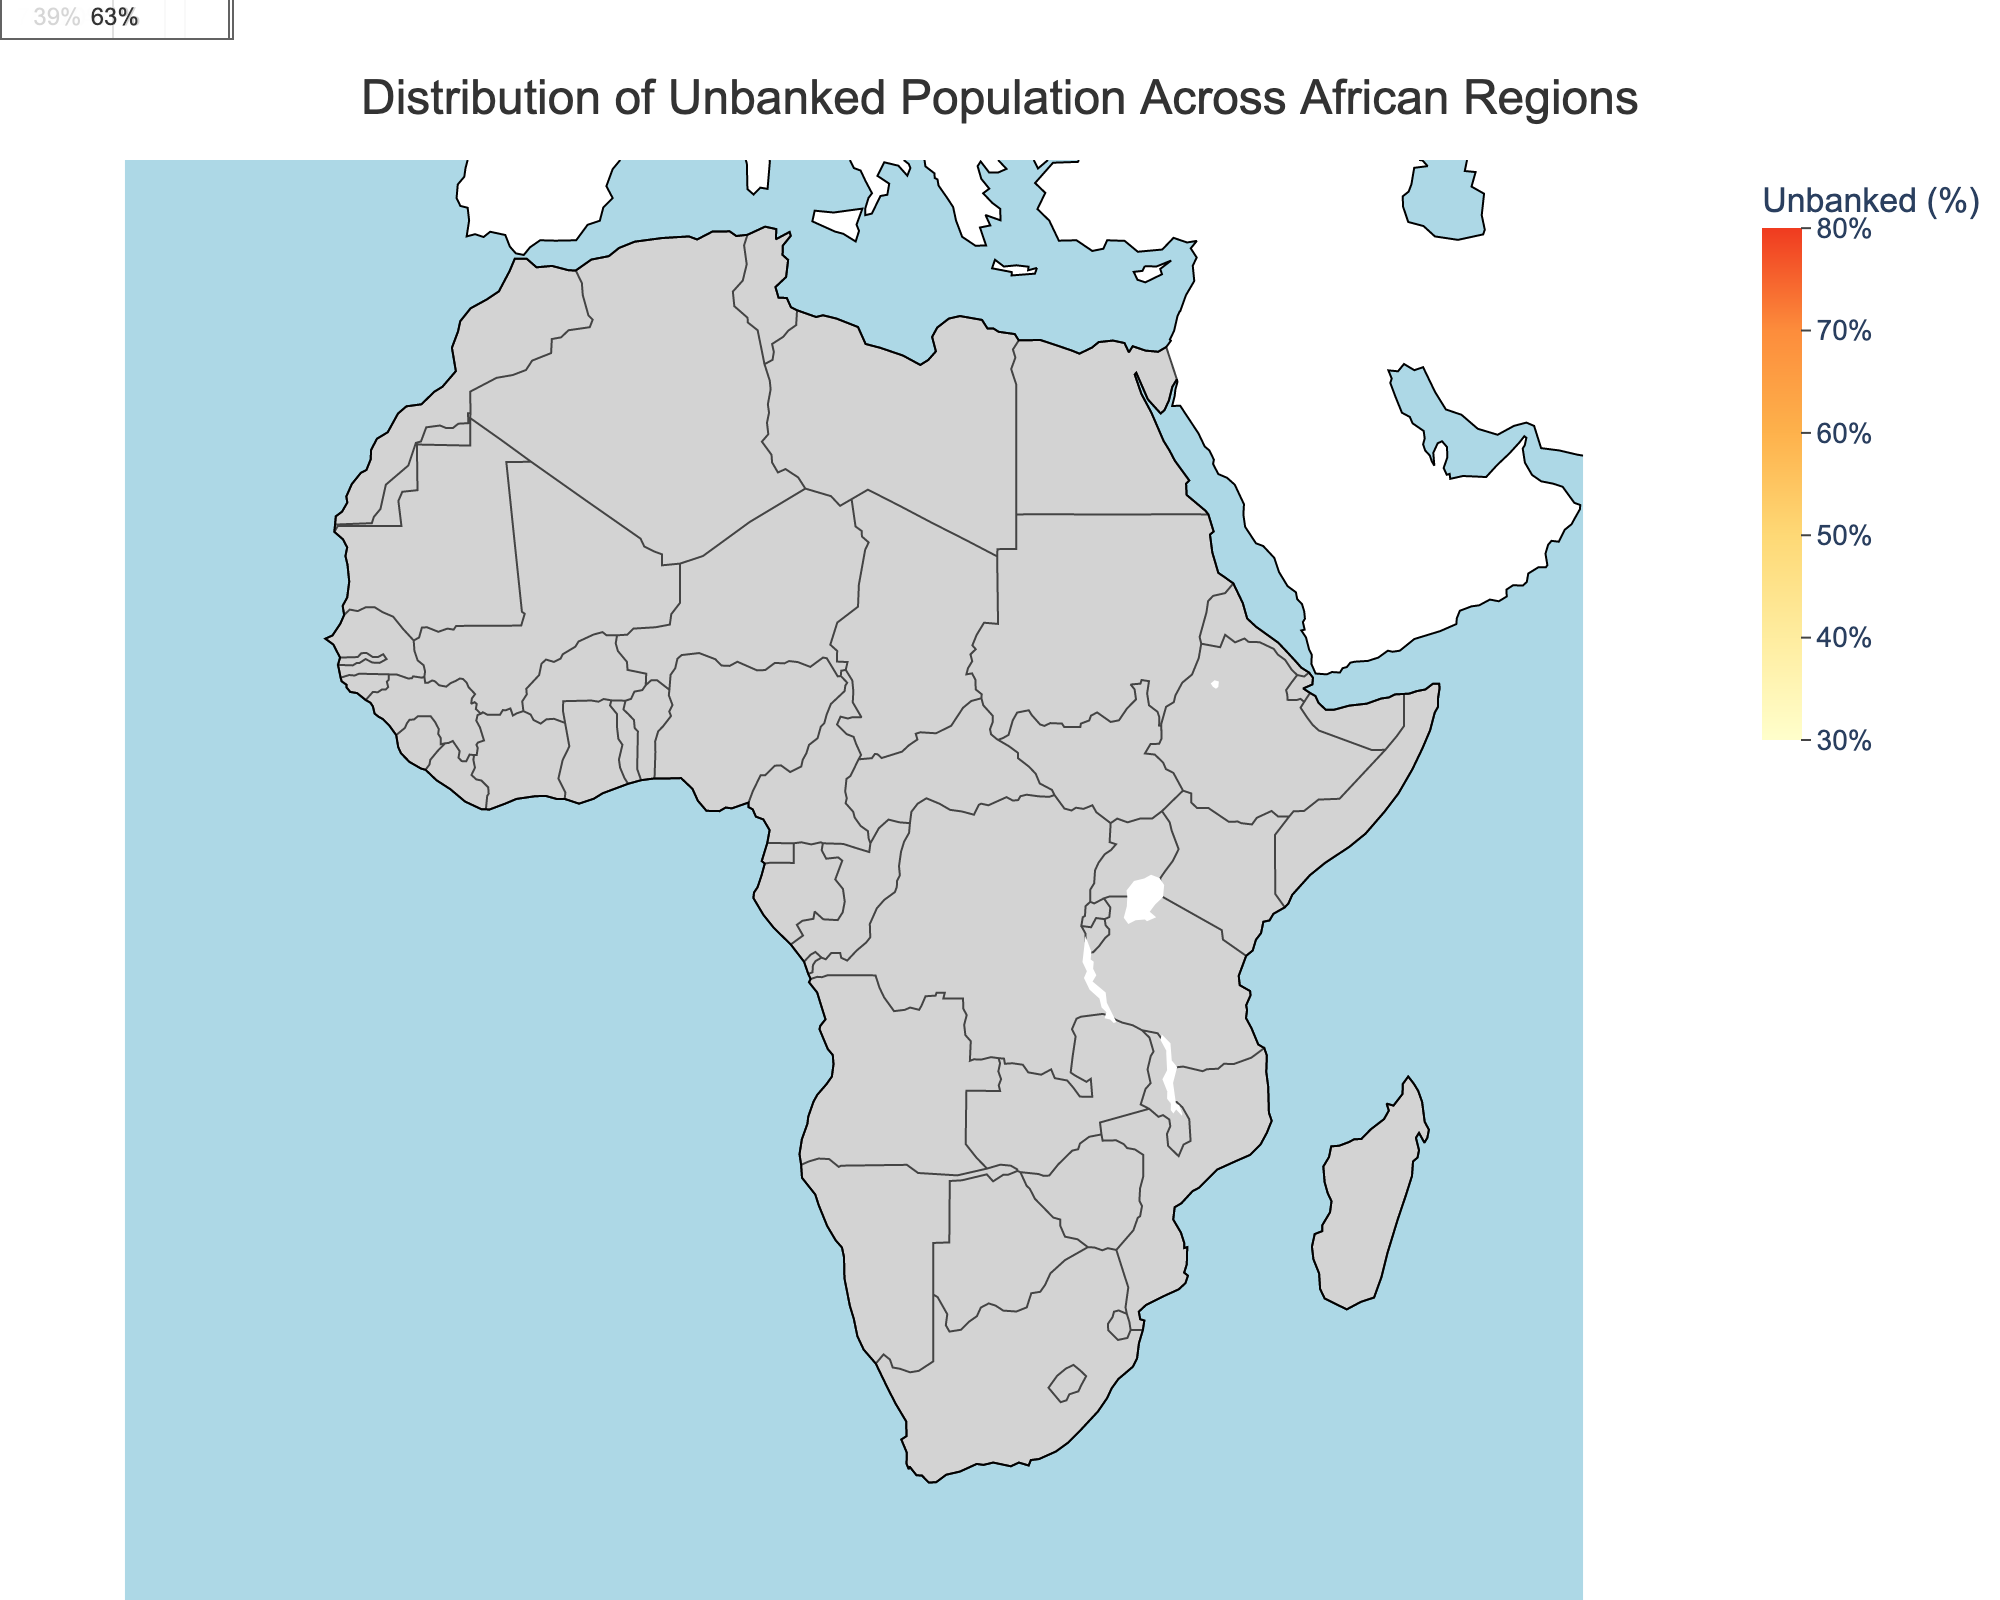What is the title of the figure? The title is usually placed at the top of the figure and is intended to provide a concise description of what the figure represents. In this case, it should describe what the map is showing.
Answer: Distribution of Unbanked Population Across African Regions Which African region has the highest percentage of the unbanked population? By examining the color intensities and the annotations, the region with the highest percentage is identified. The Sahel region is the darkest shade, indicating the highest unbanked population percentage.
Answer: Sahel Which African region has the lowest percentage of the unbanked population? Similarly, the region with the lightest color intensity indicates the lowest unbanked population percentage. The Southern Africa region is the lightest, indicating the lowest percentage of unbanked population.
Answer: Southern Africa What range of unbanked population percentages is displayed in the color bar? The color bar provides the scale used in the choropleth map, which helps in interpreting the colors. It shows the percentage range of the data being mapped.
Answer: 30% to 80% How many regions have an unbanked population percentage greater than or equal to 70%? By counting the regions on the map where the unbanked population percentage annotation is 70% or higher, we can determine this. The regions meeting this criterion are Sahel, Horn of Africa, and Central Africa.
Answer: 3 What is the unbanked population percentage for East Africa? By locating East Africa on the map and looking at its associated annotation, we can find this percentage.
Answer: 66% Which regions have an unbanked population percentage less than 40%? Scanning the colors and annotations, we can identify the regions with an unbanked population percentage less than 40%. These regions are North Africa, Southern Africa, and Maghreb.
Answer: North Africa, Southern Africa, Maghreb What is the average unbanked population percentage of Central Africa and West Africa? Adding the unbanked population percentages of Central Africa (73%) and West Africa (57%) and then dividing by 2 gives the average.
Answer: 65% Compare the unbanked population percentages between Sub-Saharan Africa and the Horn of Africa. Which one is higher? By examining the annotations on the map, we see that Sub-Saharan Africa has 63% and Horn of Africa has 70%. Thus, the Horn of Africa has a higher percentage.
Answer: Horn of Africa 